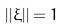<formula> <loc_0><loc_0><loc_500><loc_500>| | \xi | | = 1</formula> 